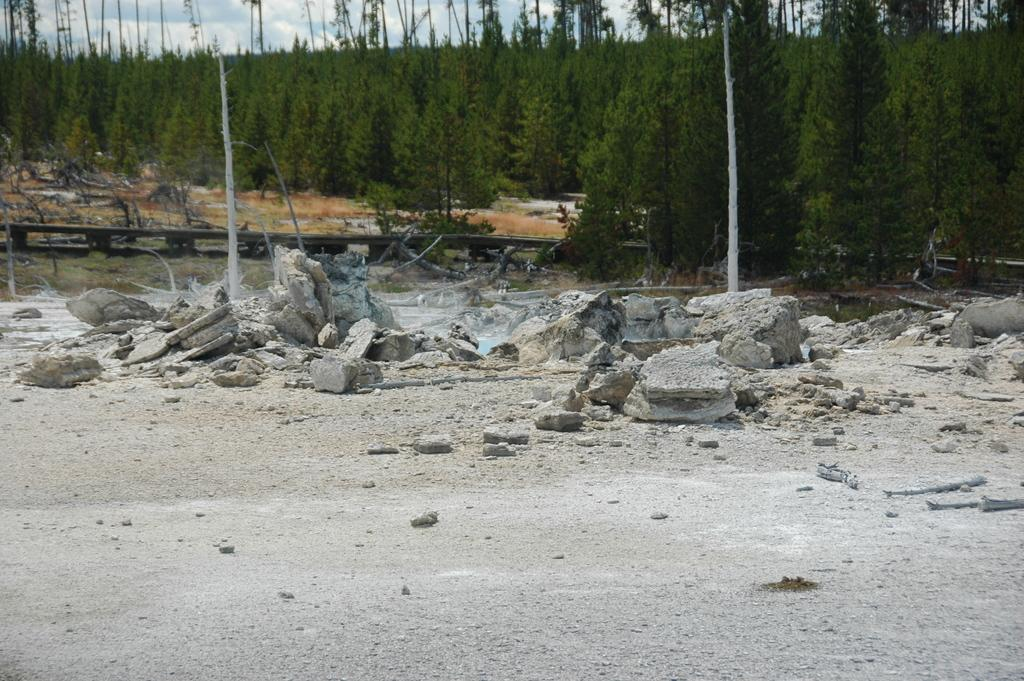What type of location is shown in the image? The image depicts an open area. What can be seen scattered throughout the open area? There are plenty of rocks in the image. What structures are visible behind the rocks? There are two poles behind the rocks. What type of vegetation is present near the poles? There are plenty of trees next to the poles. What color is the eye of the snake coiled around the pole in the image? There is no snake or eye present in the image; it only features rocks, poles, and trees. 